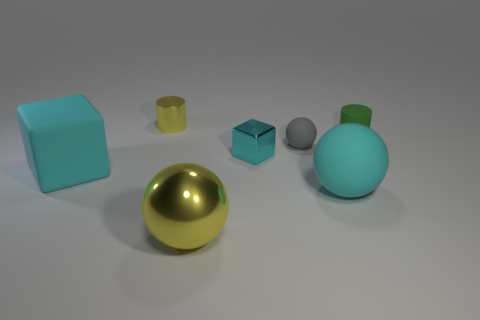How many cyan cubes must be subtracted to get 1 cyan cubes? 1 Subtract all yellow spheres. How many spheres are left? 2 Subtract all green cylinders. How many cylinders are left? 1 Subtract all brown blocks. How many green cylinders are left? 1 Add 2 yellow shiny spheres. How many yellow shiny spheres exist? 3 Add 3 tiny cyan shiny things. How many objects exist? 10 Subtract 1 yellow cylinders. How many objects are left? 6 Subtract all blocks. How many objects are left? 5 Subtract 2 cylinders. How many cylinders are left? 0 Subtract all yellow cubes. Subtract all gray balls. How many cubes are left? 2 